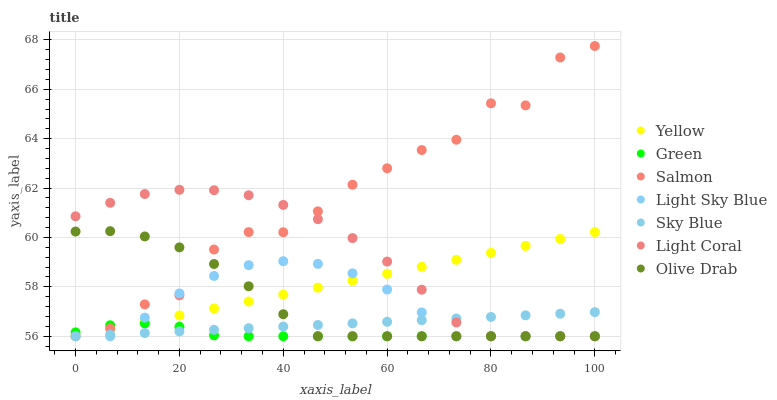Does Green have the minimum area under the curve?
Answer yes or no. Yes. Does Salmon have the maximum area under the curve?
Answer yes or no. Yes. Does Yellow have the minimum area under the curve?
Answer yes or no. No. Does Yellow have the maximum area under the curve?
Answer yes or no. No. Is Sky Blue the smoothest?
Answer yes or no. Yes. Is Salmon the roughest?
Answer yes or no. Yes. Is Yellow the smoothest?
Answer yes or no. No. Is Yellow the roughest?
Answer yes or no. No. Does Salmon have the lowest value?
Answer yes or no. Yes. Does Salmon have the highest value?
Answer yes or no. Yes. Does Yellow have the highest value?
Answer yes or no. No. Does Sky Blue intersect Olive Drab?
Answer yes or no. Yes. Is Sky Blue less than Olive Drab?
Answer yes or no. No. Is Sky Blue greater than Olive Drab?
Answer yes or no. No. 